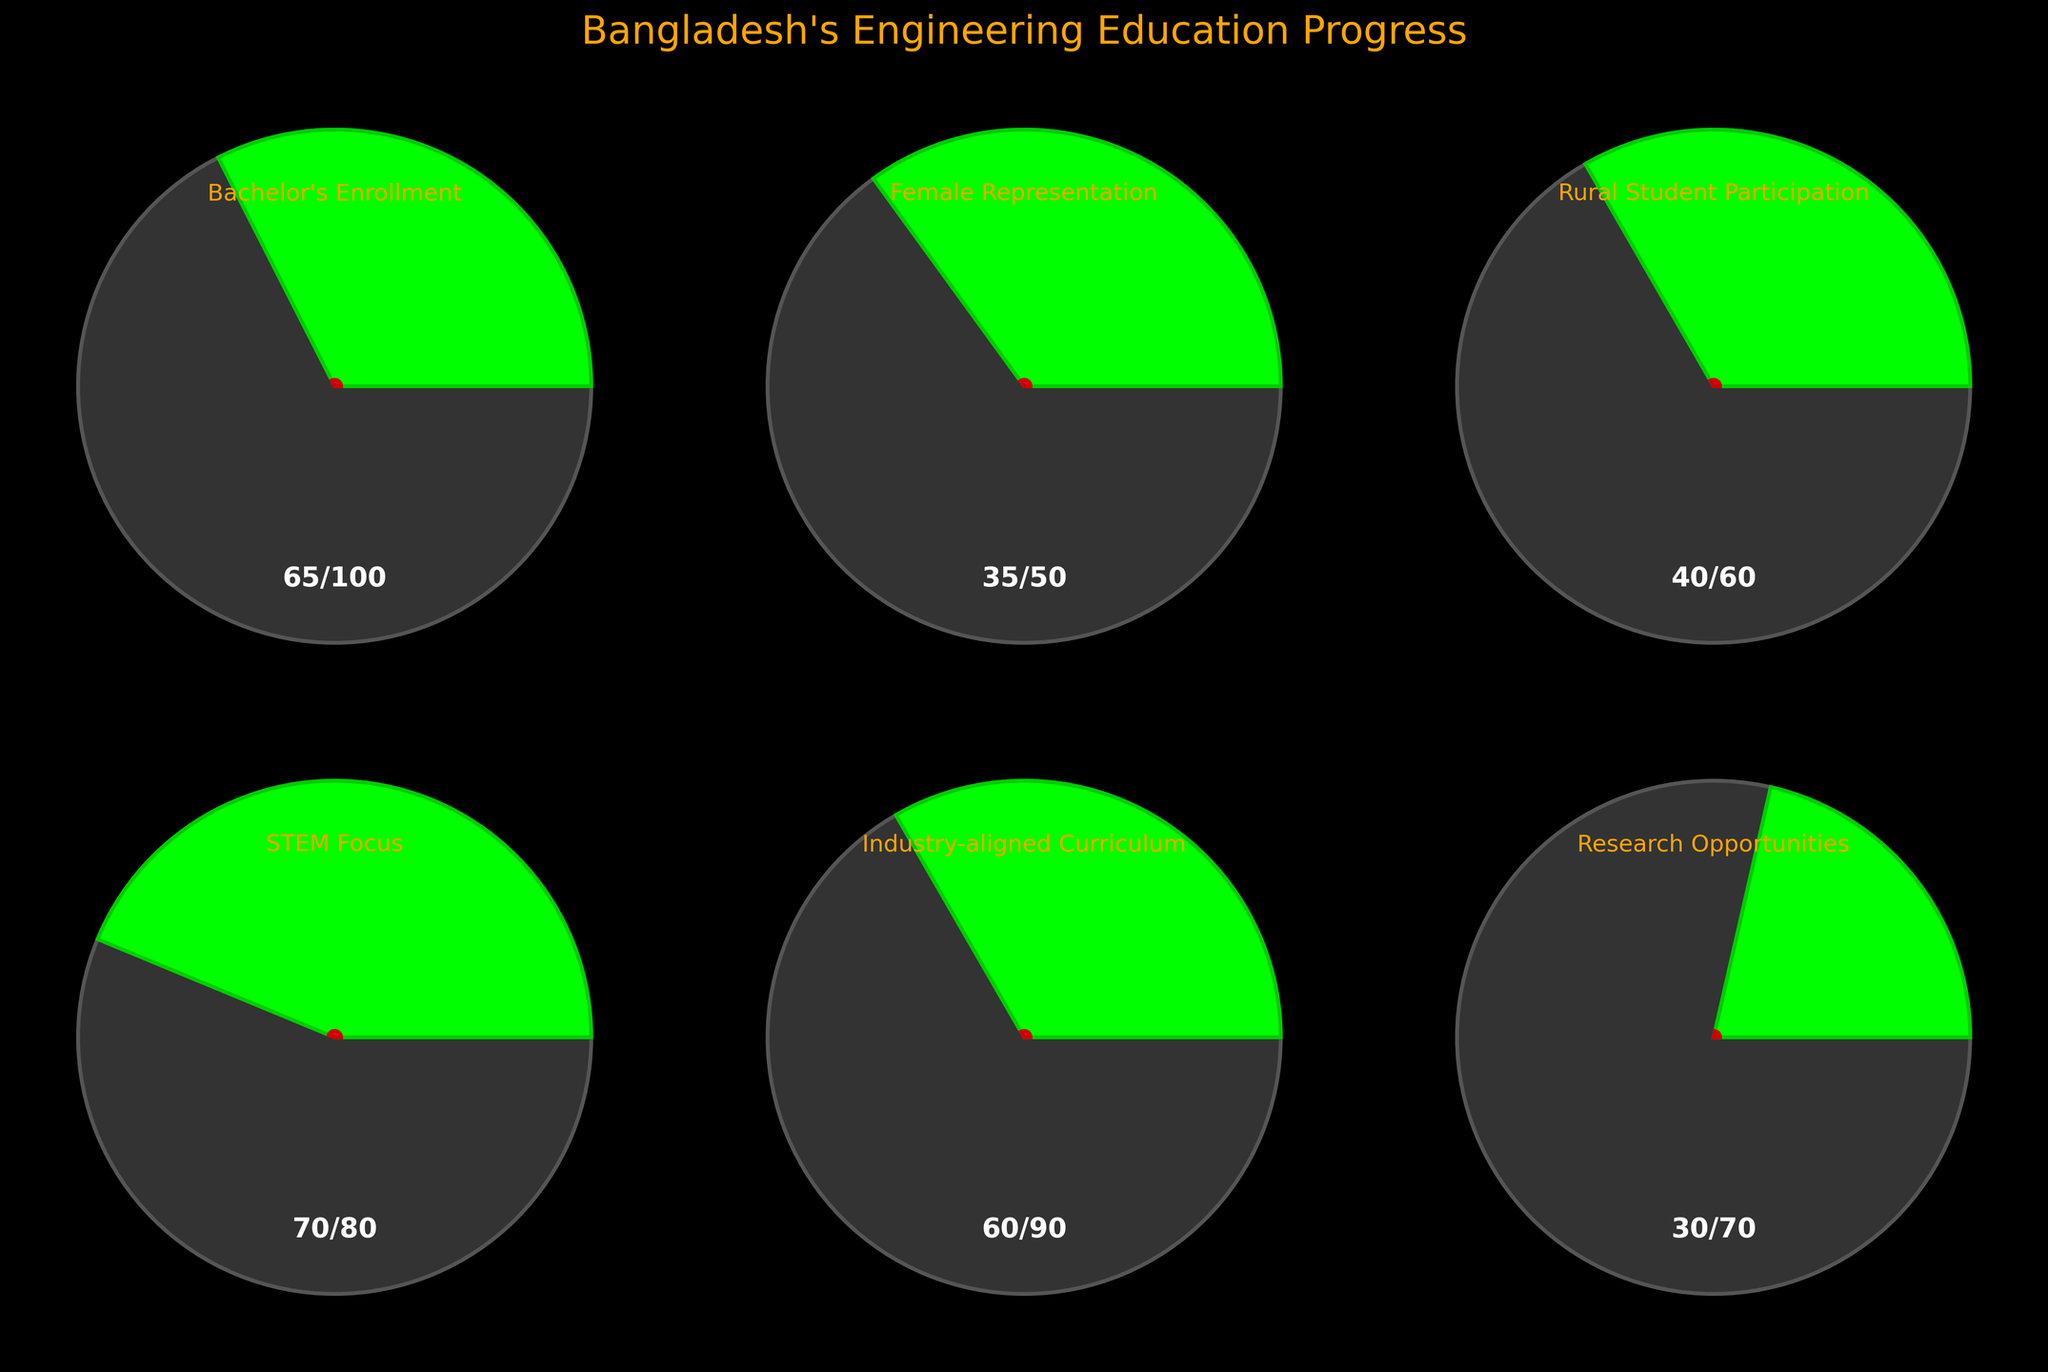What is the title of the plot? The title of the plot is the text that is prominently displayed at the top center of the figure. It provides a summary of what the figure represents. By looking at the figure, you can see that it reads "Bangladesh's Engineering Education Progress."
Answer: Bangladesh's Engineering Education Progress What category has the highest target value? To determine which category has the highest target value, you need to compare the target values of each category listed. In the data, the highest target value is 100 for "Bachelor's Enrollment."
Answer: Bachelor's Enrollment Which category is closest to reaching its target in percentage terms? To find the category closest to reaching its target, calculate the percentage achieved for each category using the formula: (Actual/Target)*100. Compare these percentages: 
- Bachelor's Enrollment: 65/100 = 65%
- Female Representation: 35/50 = 70%
- Rural Student Participation: 40/60 = 66.7%
- STEM Focus: 70/80 = 87.5%
- Industry-aligned Curriculum: 60/90 = 66.7%
- Research Opportunities: 30/70 = 42.9%
The highest percentage is for "STEM Focus" at 87.5%.
Answer: STEM Focus How many categories have a target value greater than or equal to 70? Examine the target values from the data and count the number of categories where the target value is 70 or greater. The relevant categories are:
1. Bachelor's Enrollment (100)
2. STEM Focus (80)
3. Industry-aligned Curriculum (90)
4. Research Opportunities (70)
There are 4 such categories.
Answer: 4 What is the actual value for "Female Representation"? The actual value for "Female Representation" can be found directly from the list of categories. According to the data, the actual value is 35.
Answer: 35 Which category has the smallest difference between actual and target values? To determine the smallest difference between actual and target values, calculate the differences for each category:
- Bachelor's Enrollment: 100 - 65 = 35
- Female Representation: 50 - 35 = 15
- Rural Student Participation: 60 - 40 = 20
- STEM Focus: 80 - 70 = 10
- Industry-aligned Curriculum: 90 - 60 = 30
- Research Opportunities: 70 - 30 = 40
The smallest difference is 10 for "STEM Focus."
Answer: STEM Focus Which category has the highest actual value? Compare the actual values of all categories listed, and identify the maximum value. For the given data, the highest actual value is 70 for "STEM Focus."
Answer: STEM Focus 